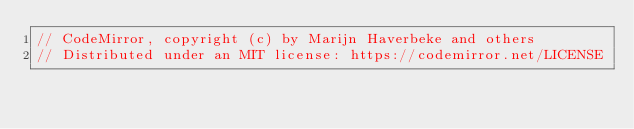<code> <loc_0><loc_0><loc_500><loc_500><_JavaScript_>// CodeMirror, copyright (c) by Marijn Haverbeke and others
// Distributed under an MIT license: https://codemirror.net/LICENSE</code> 